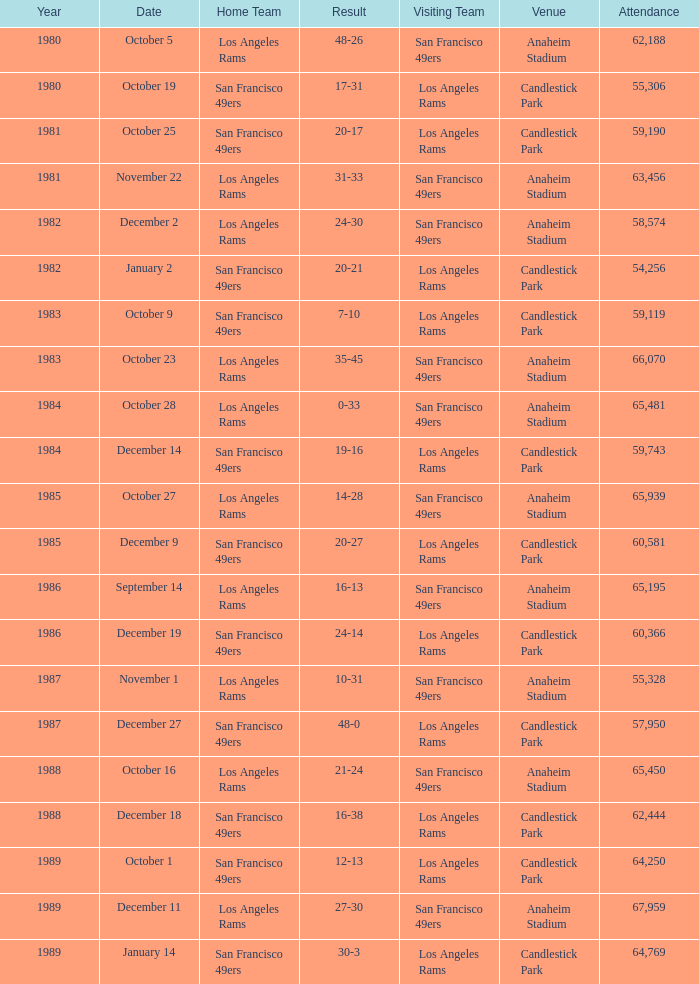What's the aggregate attendance at anaheim stadium following 1983 when the scoreline is 14-28? 1.0. 